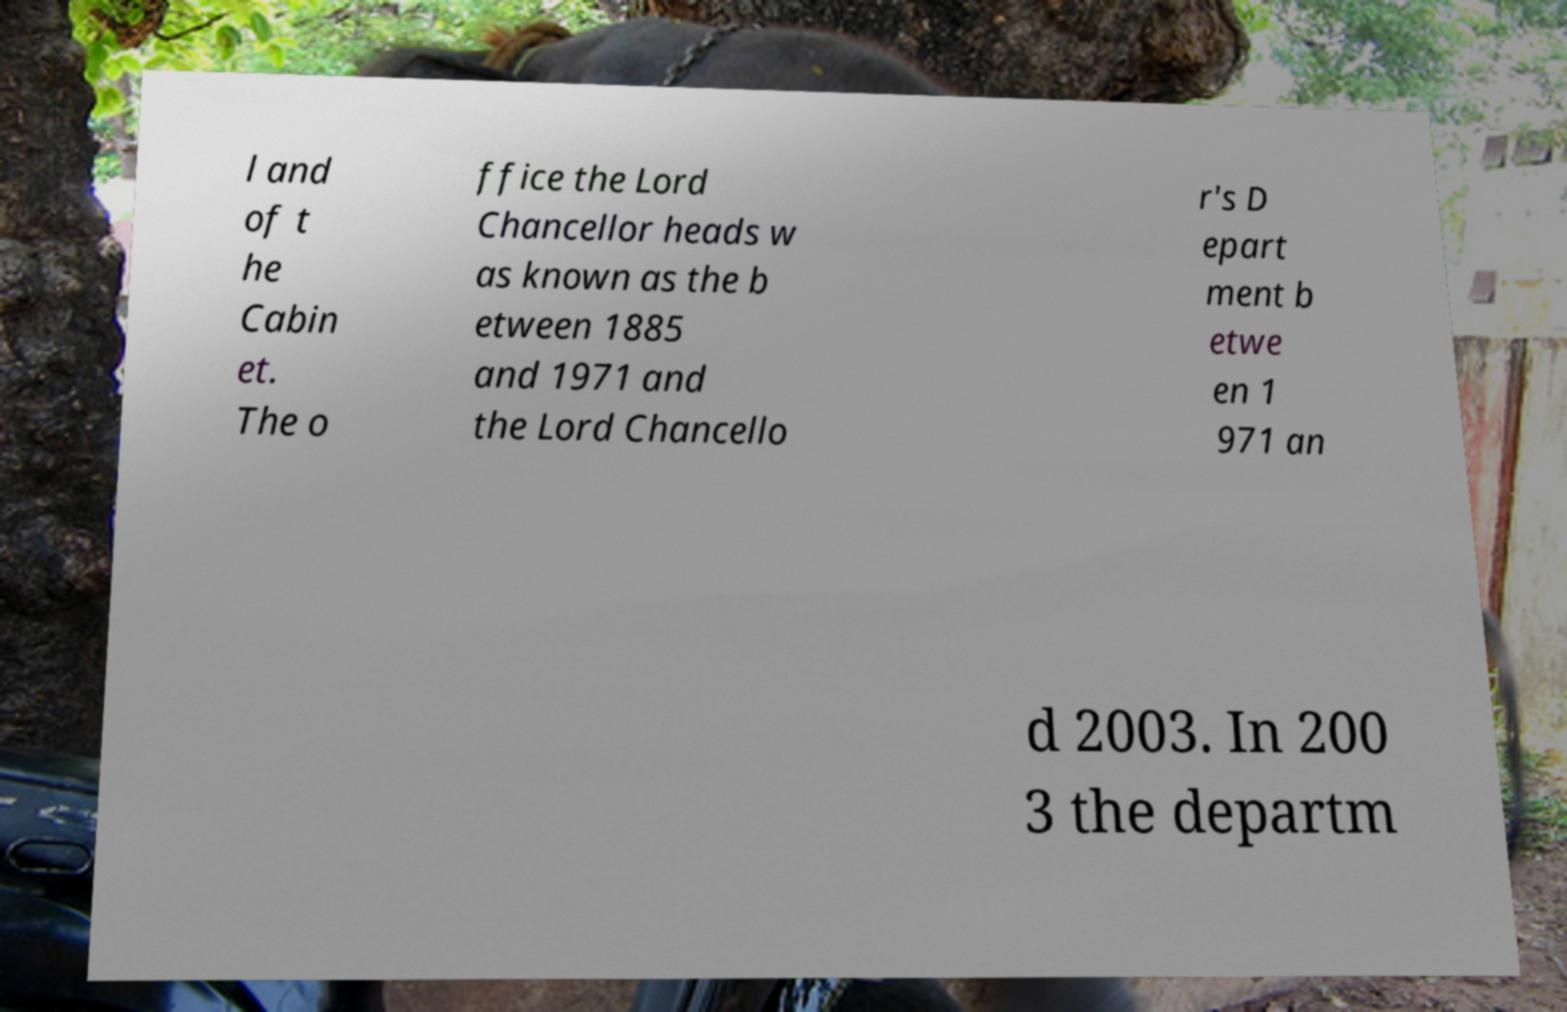Can you accurately transcribe the text from the provided image for me? l and of t he Cabin et. The o ffice the Lord Chancellor heads w as known as the b etween 1885 and 1971 and the Lord Chancello r's D epart ment b etwe en 1 971 an d 2003. In 200 3 the departm 